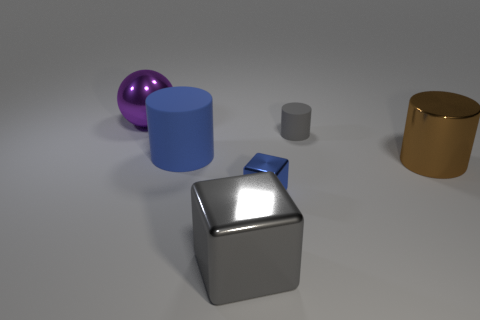Is there a block that has the same color as the small rubber cylinder?
Provide a succinct answer. Yes. There is a matte object that is right of the large cube; what is its size?
Offer a terse response. Small. What is the color of the large cylinder that is to the left of the cylinder that is to the right of the matte cylinder that is to the right of the gray shiny block?
Give a very brief answer. Blue. Is the color of the large rubber cylinder the same as the small shiny cube?
Offer a terse response. Yes. What number of metallic things are behind the large gray metallic cube and in front of the large matte cylinder?
Your answer should be very brief. 2. How many matte things are either tiny gray blocks or small cubes?
Your response must be concise. 0. There is a thing behind the gray object behind the large blue matte thing; what is its material?
Give a very brief answer. Metal. What is the shape of the metallic thing that is the same color as the big rubber cylinder?
Provide a succinct answer. Cube. There is a matte thing that is the same size as the purple metal thing; what is its shape?
Offer a very short reply. Cylinder. Is the number of big brown cylinders less than the number of blue objects?
Provide a short and direct response. Yes. 